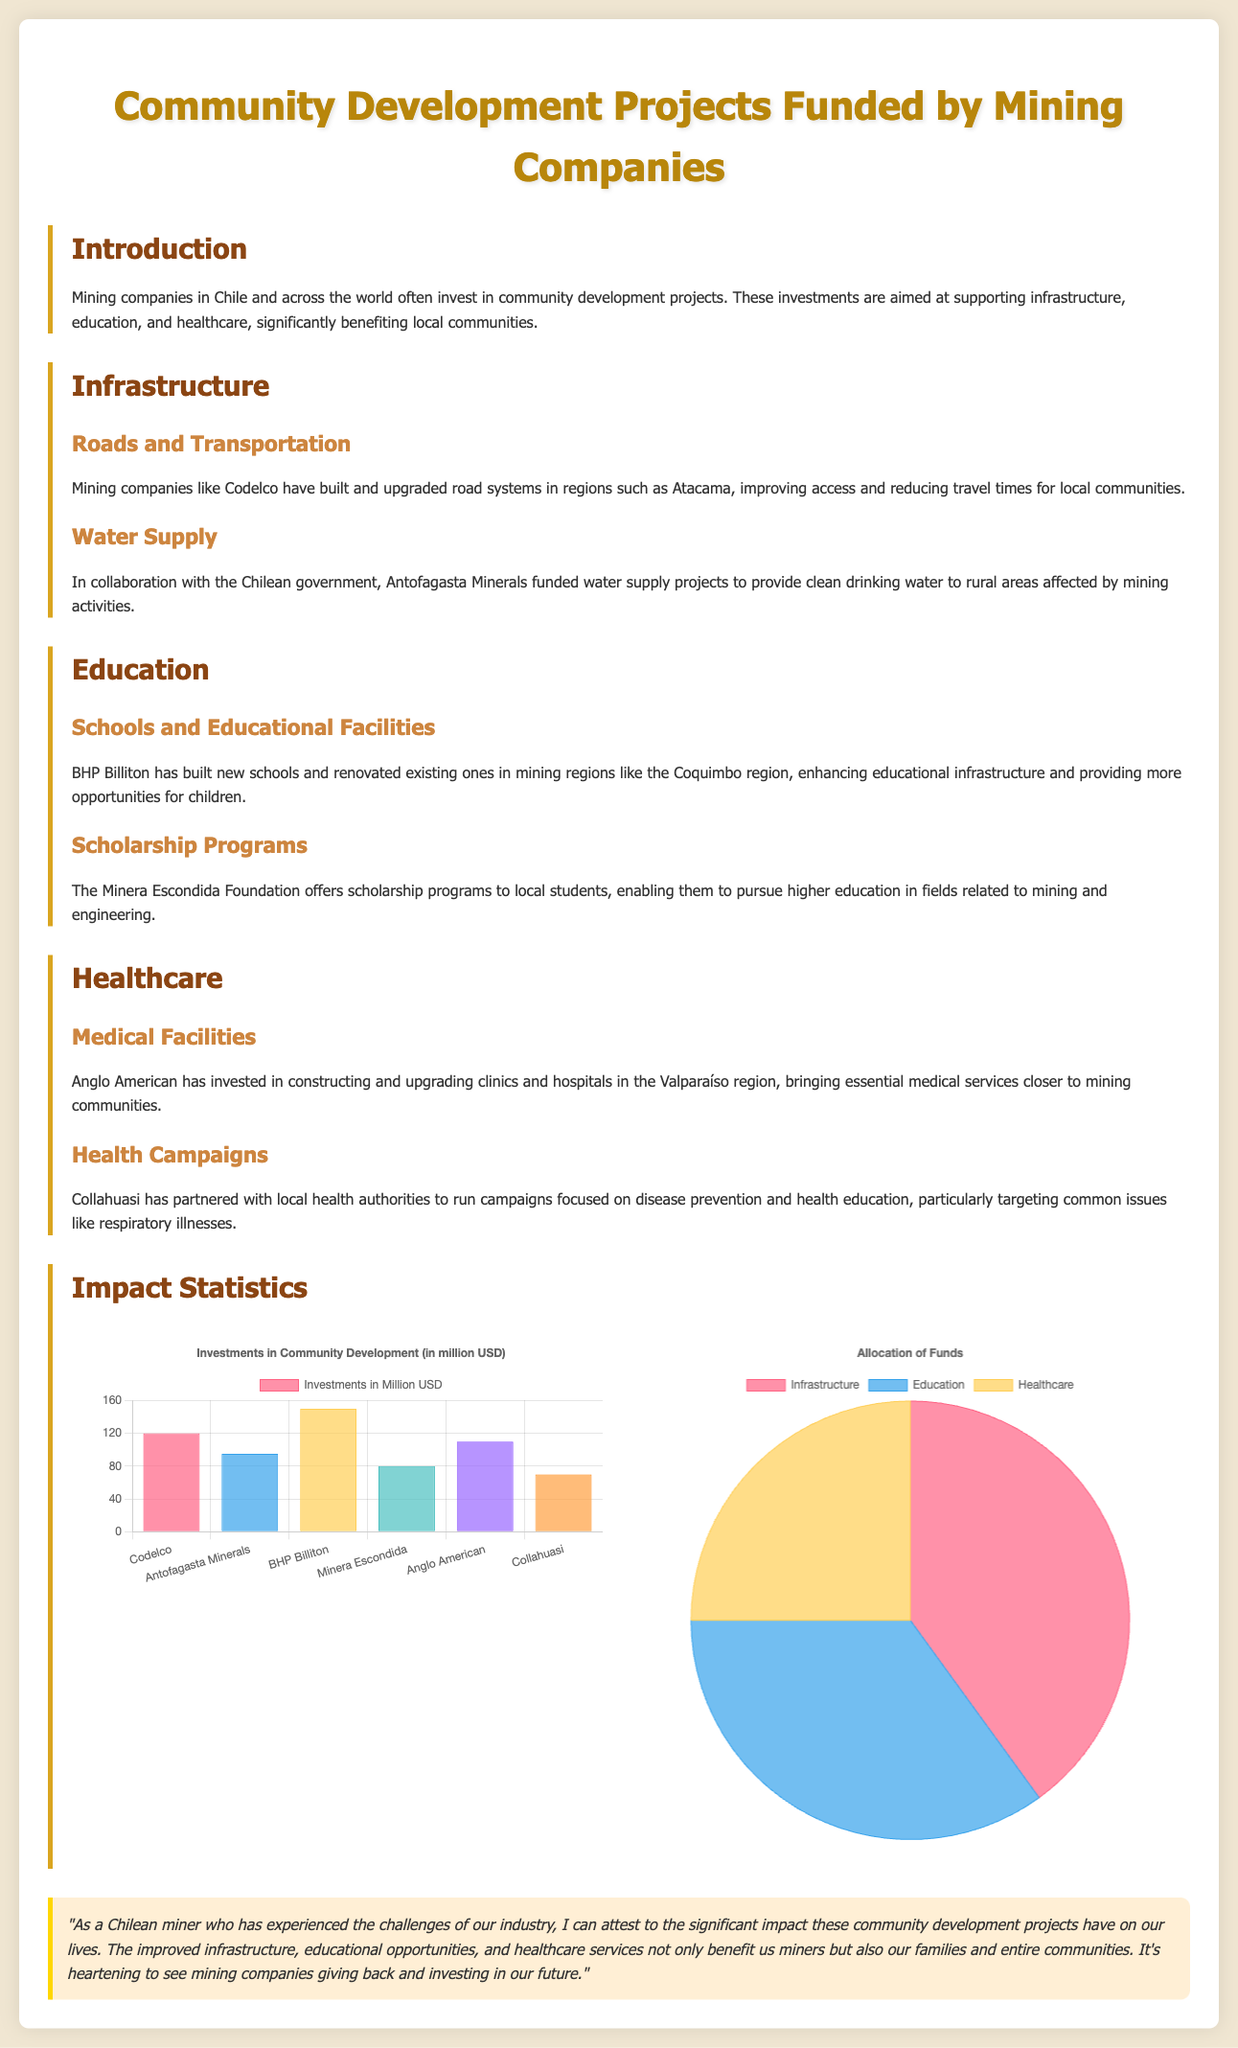what is the total investment by BHP Billiton? The total investment by BHP Billiton is explicitly mentioned in the chart as part of the investments in community development.
Answer: 150 million USD which company funded water supply projects? The document specifies that Antofagasta Minerals collaborated with the Chilean government on water supply projects.
Answer: Antofagasta Minerals what percentage of funds is allocated to healthcare? The allocation of funds pie chart shows the distribution of funds among different sectors, indicating healthcare's share.
Answer: 25 who offers scholarship programs to local students? The document states that the Minera Escondida Foundation is responsible for offering scholarship programs.
Answer: Minera Escondida Foundation which region saw improvements in roads and transportation by Codelco? Specific regions where Codelco has improved roads are mentioned in the infrastructure section, focusing on the Atacama region.
Answer: Atacama which company invested in medical facilities in the Valparaíso region? The document specifies that Anglo American has invested in medical facilities in this area.
Answer: Anglo American what is the total investment by Collahuasi? The total investment by Collahuasi is listed alongside other companies in the chart.
Answer: 70 million USD what is the main focus of health campaigns mentioned? The health campaigns aimed at addressing issues related to common health problems are highlighted, particularly respiratory illnesses.
Answer: Respiratory illnesses 